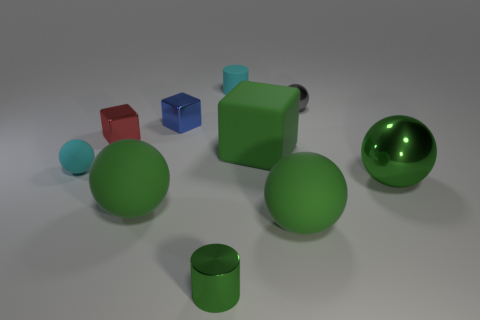Subtract all red cubes. How many green spheres are left? 3 Subtract 2 balls. How many balls are left? 3 Subtract all gray balls. How many balls are left? 4 Subtract all purple spheres. Subtract all brown cylinders. How many spheres are left? 5 Subtract all blocks. How many objects are left? 7 Add 7 rubber cylinders. How many rubber cylinders are left? 8 Add 8 small green cylinders. How many small green cylinders exist? 9 Subtract 0 purple cylinders. How many objects are left? 10 Subtract all green matte things. Subtract all small cyan cylinders. How many objects are left? 6 